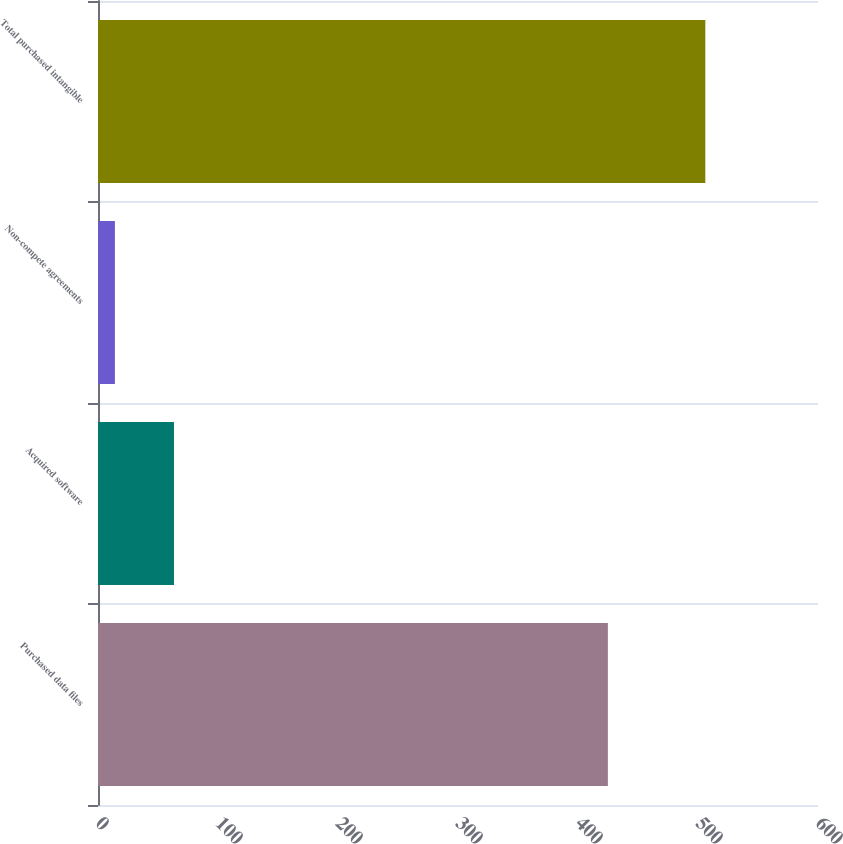<chart> <loc_0><loc_0><loc_500><loc_500><bar_chart><fcel>Purchased data files<fcel>Acquired software<fcel>Non-compete agreements<fcel>Total purchased intangible<nl><fcel>424.9<fcel>63.3<fcel>14.1<fcel>506.1<nl></chart> 